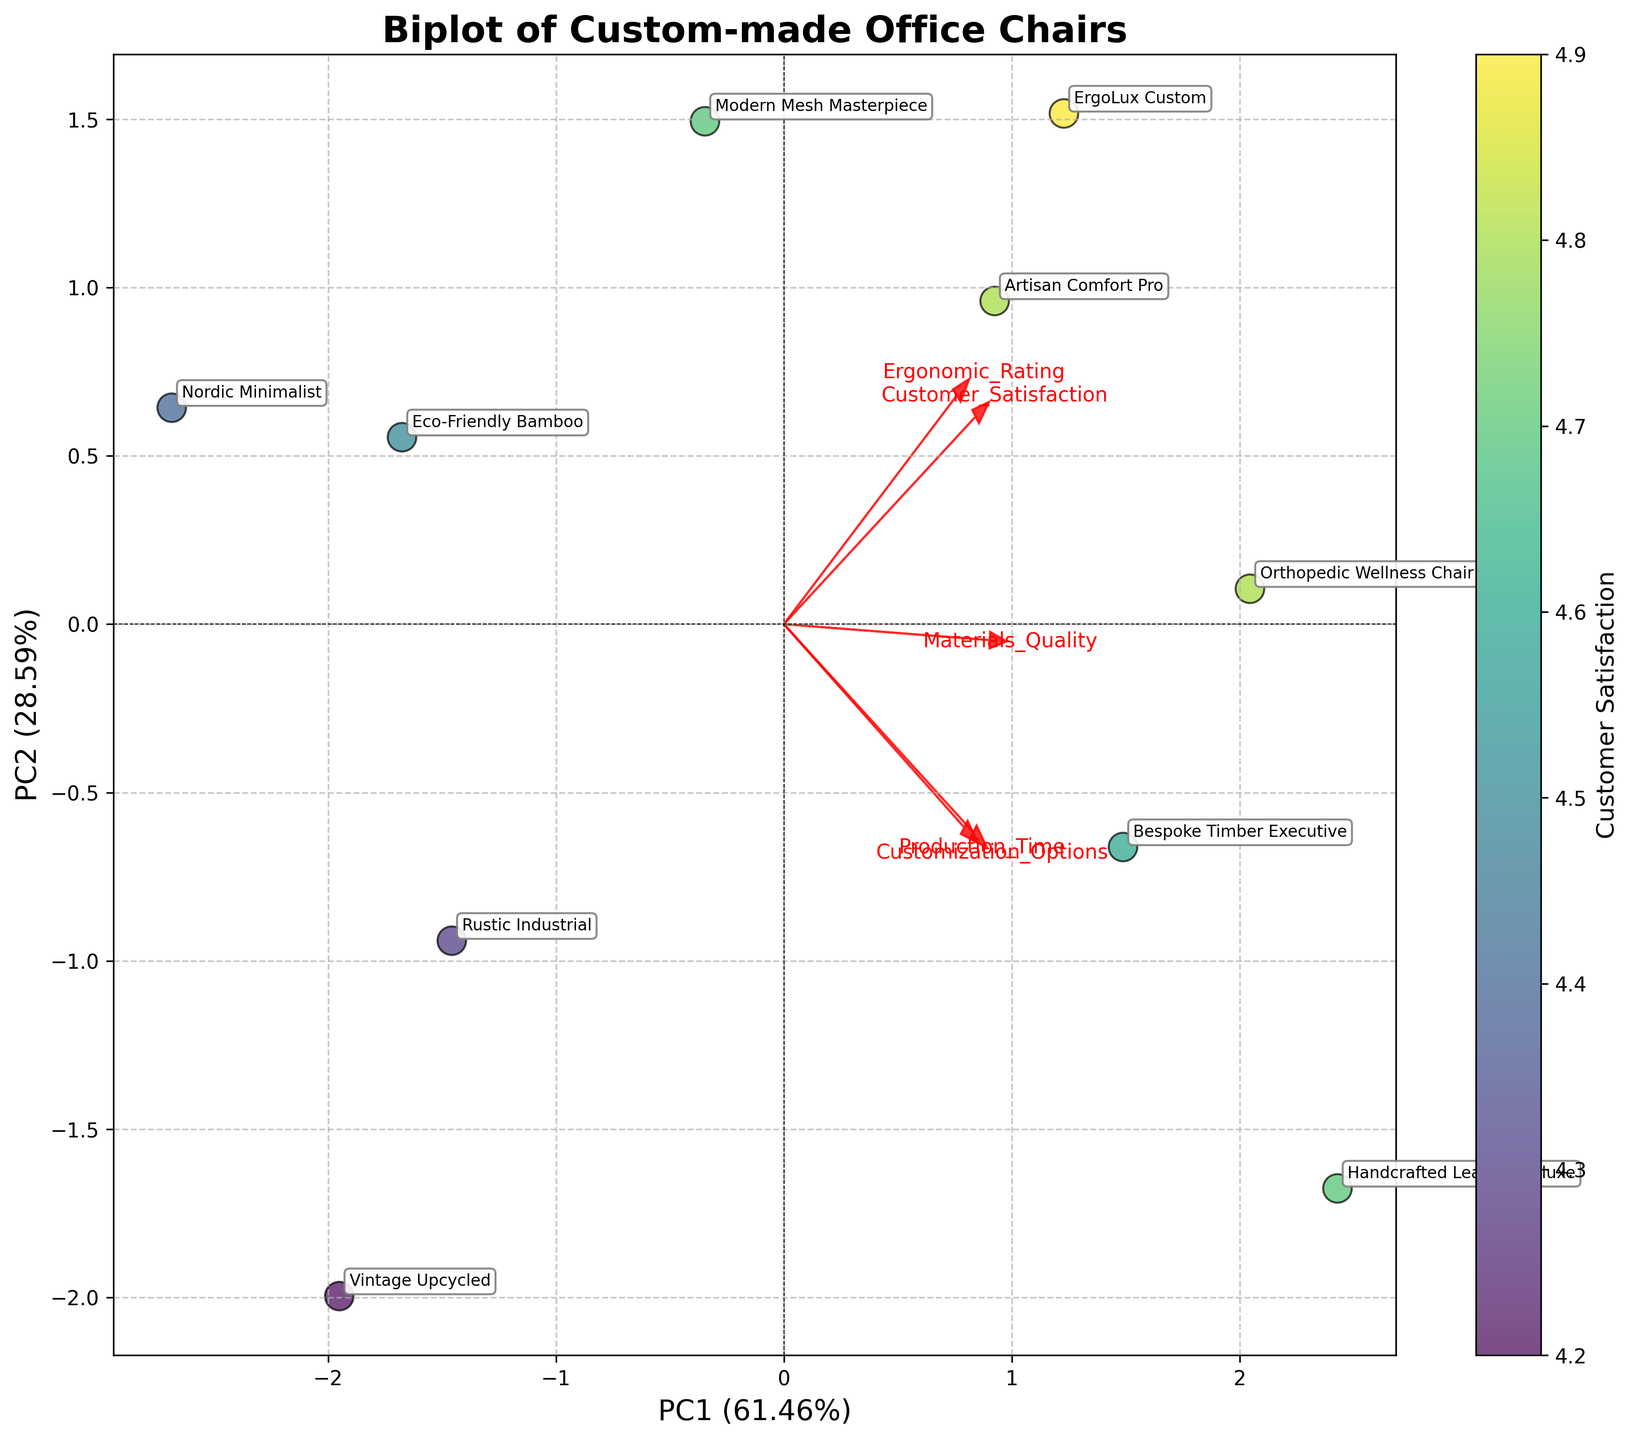How many chair models are shown in the plot? Count the number of unique data points labelled with chair model names on the plot. Each point represents a unique chair model.
Answer: 10 Which feature has the highest loading on the first principal component (PC1)? Observe the arrows representing features, and see which one extends farthest along the PC1 axis. Identify the label attached to this arrow.
Answer: Ergonomic_Rating What percentage of variance is explained by the first principal component (PC1) and the second principal component (PC2) combined? Sum the percentages of the explained variance for PC1 and PC2, as indicated on the axes labels.
Answer: Approximately 75% Which chair model appears closest to the origin in the biplot? Identify the chair model label that is nearest to the (0, 0) point on the plot. This involves looking at the annotations.
Answer: Vintage Upcycled How do 'Production_Time' and 'Ergonomic_Rating' correlate with each other according to the biplot? Observe the direction of the arrows for 'Production_Time' and 'Ergonomic_Rating'. If they point in roughly the same direction, they are positively correlated; if they point in opposite directions, they are negatively correlated.
Answer: Positively correlated Which chair model has the highest Customer Satisfaction rating in the plot? The color intensity, as indicated by the colorbar, represents Customer Satisfaction ratings. Identify the point with the most intense color and note the associated chair model label.
Answer: ErgoLux Custom Are 'Materials_Quality' and 'Customization_Options' more strongly correlated with PC1 or PC2? Look at the direction and length of the arrows for 'Materials_Quality' and 'Customization_Options'. Determine along which principal component (PC1 or PC2) they show stronger loadings (larger projections).
Answer: PC2 Which chair model has the longest production time and where is it located on the biplot? The production time information is encoded in the position of 'Production_Time' on the plot. Identify which labeled point corresponds to the longest arrow in the direction of 'Production_Time'.
Answer: Handcrafted Leather Deluxe 